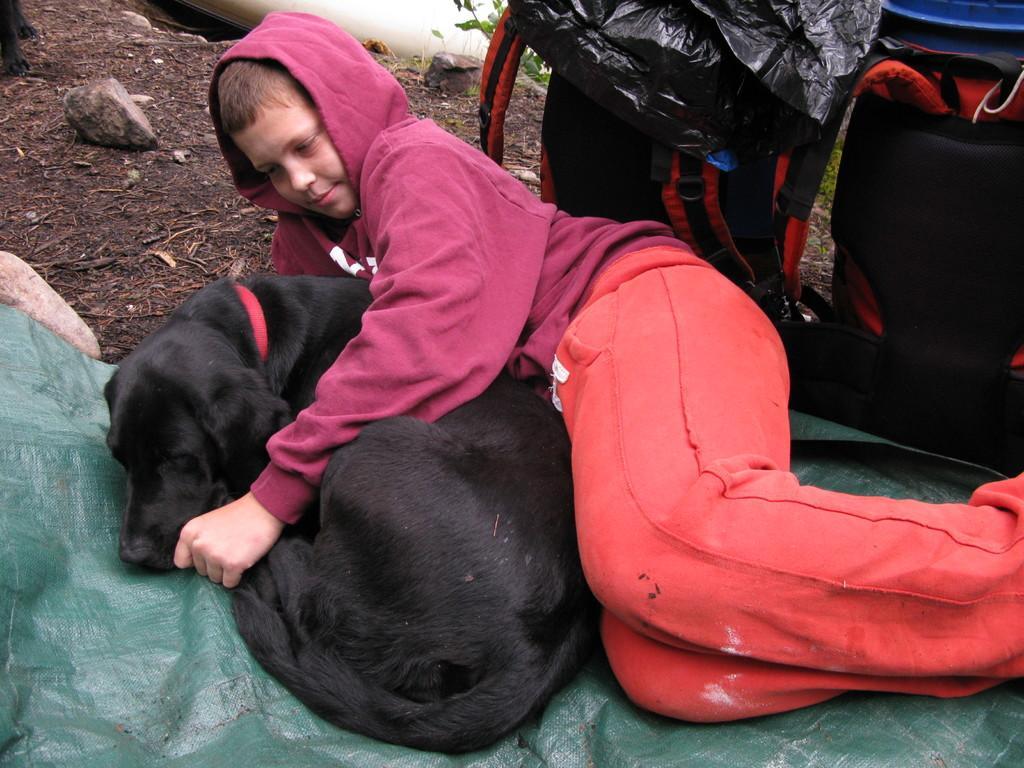Please provide a concise description of this image. In the picture I can see a boy and he is looking at a dog which is beside to him. I can see the bags on the right side. There are stones on the top left side. 